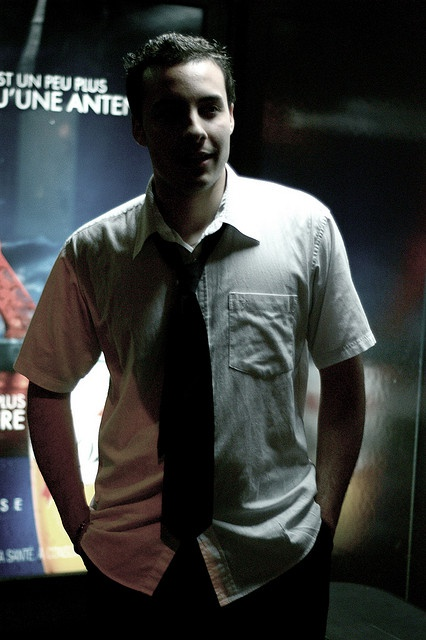Describe the objects in this image and their specific colors. I can see people in black, gray, white, and maroon tones and tie in black and gray tones in this image. 